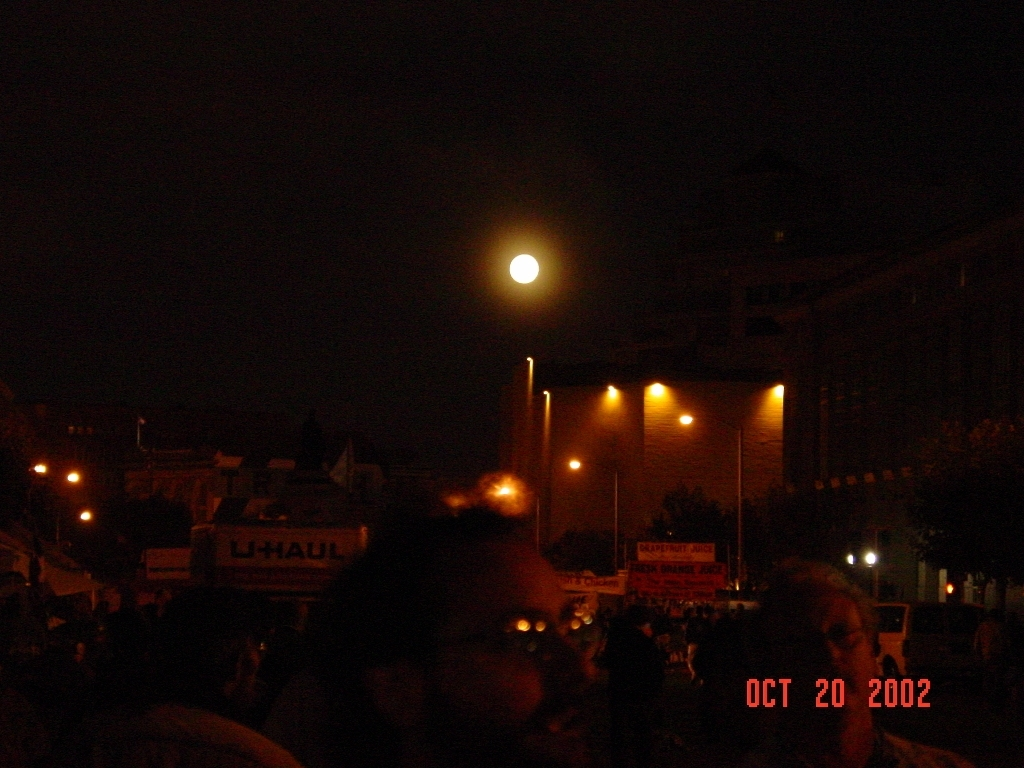Can you describe the activity or event that seems to be occurring in this image? The image captures a scene that suggests a gathering or event, likely outdoors, as evidenced by the crowd of people partially visible at the bottom. The array of lights and darkness suggest it might be taking place during the evening or at night. What do the people's presence and the lighting tell us about the type of event it might be? Considering the outdoor setting, the nighttime lighting, and the informal gathering of people, it could be a public event such as a festival, concert, or a community gathering. The lighting provides enough visibility for safety while setting a relaxed ambiance suited for social or entertainment purposes. 